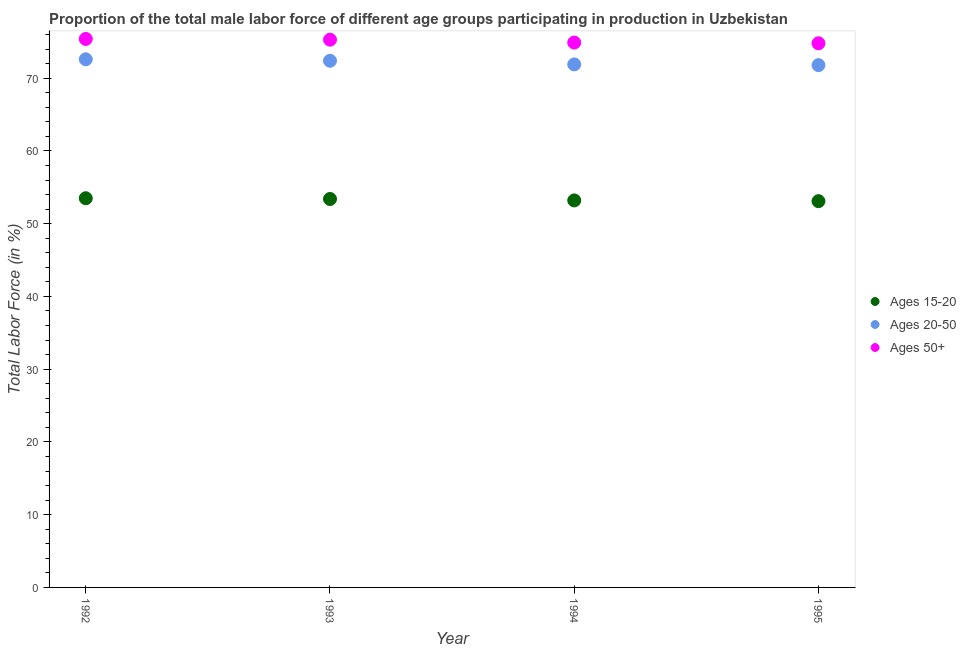How many different coloured dotlines are there?
Give a very brief answer. 3. Is the number of dotlines equal to the number of legend labels?
Offer a very short reply. Yes. What is the percentage of male labor force within the age group 15-20 in 1992?
Your answer should be compact. 53.5. Across all years, what is the maximum percentage of male labor force within the age group 15-20?
Keep it short and to the point. 53.5. Across all years, what is the minimum percentage of male labor force within the age group 20-50?
Offer a terse response. 71.8. In which year was the percentage of male labor force within the age group 15-20 maximum?
Make the answer very short. 1992. What is the total percentage of male labor force within the age group 15-20 in the graph?
Keep it short and to the point. 213.2. What is the difference between the percentage of male labor force within the age group 15-20 in 1992 and that in 1993?
Offer a very short reply. 0.1. What is the difference between the percentage of male labor force within the age group 15-20 in 1994 and the percentage of male labor force within the age group 20-50 in 1995?
Your response must be concise. -18.6. What is the average percentage of male labor force within the age group 15-20 per year?
Make the answer very short. 53.3. What is the ratio of the percentage of male labor force above age 50 in 1993 to that in 1995?
Provide a succinct answer. 1.01. Is the percentage of male labor force within the age group 20-50 in 1992 less than that in 1993?
Your response must be concise. No. Is the difference between the percentage of male labor force above age 50 in 1992 and 1993 greater than the difference between the percentage of male labor force within the age group 15-20 in 1992 and 1993?
Offer a very short reply. Yes. What is the difference between the highest and the second highest percentage of male labor force above age 50?
Ensure brevity in your answer.  0.1. What is the difference between the highest and the lowest percentage of male labor force within the age group 20-50?
Your answer should be compact. 0.8. In how many years, is the percentage of male labor force above age 50 greater than the average percentage of male labor force above age 50 taken over all years?
Give a very brief answer. 2. Does the percentage of male labor force above age 50 monotonically increase over the years?
Your answer should be very brief. No. Is the percentage of male labor force within the age group 20-50 strictly greater than the percentage of male labor force above age 50 over the years?
Your response must be concise. No. How many dotlines are there?
Ensure brevity in your answer.  3. Are the values on the major ticks of Y-axis written in scientific E-notation?
Your answer should be compact. No. Does the graph contain grids?
Keep it short and to the point. No. Where does the legend appear in the graph?
Your response must be concise. Center right. What is the title of the graph?
Give a very brief answer. Proportion of the total male labor force of different age groups participating in production in Uzbekistan. What is the label or title of the X-axis?
Offer a very short reply. Year. What is the label or title of the Y-axis?
Make the answer very short. Total Labor Force (in %). What is the Total Labor Force (in %) of Ages 15-20 in 1992?
Offer a very short reply. 53.5. What is the Total Labor Force (in %) in Ages 20-50 in 1992?
Provide a short and direct response. 72.6. What is the Total Labor Force (in %) in Ages 50+ in 1992?
Provide a short and direct response. 75.4. What is the Total Labor Force (in %) in Ages 15-20 in 1993?
Offer a very short reply. 53.4. What is the Total Labor Force (in %) in Ages 20-50 in 1993?
Your response must be concise. 72.4. What is the Total Labor Force (in %) in Ages 50+ in 1993?
Ensure brevity in your answer.  75.3. What is the Total Labor Force (in %) in Ages 15-20 in 1994?
Offer a terse response. 53.2. What is the Total Labor Force (in %) of Ages 20-50 in 1994?
Keep it short and to the point. 71.9. What is the Total Labor Force (in %) of Ages 50+ in 1994?
Offer a very short reply. 74.9. What is the Total Labor Force (in %) of Ages 15-20 in 1995?
Keep it short and to the point. 53.1. What is the Total Labor Force (in %) in Ages 20-50 in 1995?
Provide a short and direct response. 71.8. What is the Total Labor Force (in %) of Ages 50+ in 1995?
Keep it short and to the point. 74.8. Across all years, what is the maximum Total Labor Force (in %) of Ages 15-20?
Provide a succinct answer. 53.5. Across all years, what is the maximum Total Labor Force (in %) of Ages 20-50?
Offer a terse response. 72.6. Across all years, what is the maximum Total Labor Force (in %) of Ages 50+?
Provide a succinct answer. 75.4. Across all years, what is the minimum Total Labor Force (in %) in Ages 15-20?
Keep it short and to the point. 53.1. Across all years, what is the minimum Total Labor Force (in %) of Ages 20-50?
Make the answer very short. 71.8. Across all years, what is the minimum Total Labor Force (in %) in Ages 50+?
Ensure brevity in your answer.  74.8. What is the total Total Labor Force (in %) of Ages 15-20 in the graph?
Keep it short and to the point. 213.2. What is the total Total Labor Force (in %) of Ages 20-50 in the graph?
Ensure brevity in your answer.  288.7. What is the total Total Labor Force (in %) of Ages 50+ in the graph?
Give a very brief answer. 300.4. What is the difference between the Total Labor Force (in %) in Ages 15-20 in 1992 and that in 1993?
Keep it short and to the point. 0.1. What is the difference between the Total Labor Force (in %) of Ages 20-50 in 1992 and that in 1993?
Offer a very short reply. 0.2. What is the difference between the Total Labor Force (in %) of Ages 50+ in 1992 and that in 1994?
Your response must be concise. 0.5. What is the difference between the Total Labor Force (in %) of Ages 50+ in 1992 and that in 1995?
Your response must be concise. 0.6. What is the difference between the Total Labor Force (in %) of Ages 15-20 in 1993 and that in 1994?
Your answer should be compact. 0.2. What is the difference between the Total Labor Force (in %) of Ages 15-20 in 1993 and that in 1995?
Offer a very short reply. 0.3. What is the difference between the Total Labor Force (in %) of Ages 20-50 in 1993 and that in 1995?
Your answer should be very brief. 0.6. What is the difference between the Total Labor Force (in %) of Ages 50+ in 1994 and that in 1995?
Your answer should be compact. 0.1. What is the difference between the Total Labor Force (in %) in Ages 15-20 in 1992 and the Total Labor Force (in %) in Ages 20-50 in 1993?
Provide a succinct answer. -18.9. What is the difference between the Total Labor Force (in %) in Ages 15-20 in 1992 and the Total Labor Force (in %) in Ages 50+ in 1993?
Offer a very short reply. -21.8. What is the difference between the Total Labor Force (in %) in Ages 15-20 in 1992 and the Total Labor Force (in %) in Ages 20-50 in 1994?
Your answer should be compact. -18.4. What is the difference between the Total Labor Force (in %) in Ages 15-20 in 1992 and the Total Labor Force (in %) in Ages 50+ in 1994?
Keep it short and to the point. -21.4. What is the difference between the Total Labor Force (in %) in Ages 15-20 in 1992 and the Total Labor Force (in %) in Ages 20-50 in 1995?
Ensure brevity in your answer.  -18.3. What is the difference between the Total Labor Force (in %) of Ages 15-20 in 1992 and the Total Labor Force (in %) of Ages 50+ in 1995?
Provide a succinct answer. -21.3. What is the difference between the Total Labor Force (in %) in Ages 20-50 in 1992 and the Total Labor Force (in %) in Ages 50+ in 1995?
Make the answer very short. -2.2. What is the difference between the Total Labor Force (in %) of Ages 15-20 in 1993 and the Total Labor Force (in %) of Ages 20-50 in 1994?
Provide a short and direct response. -18.5. What is the difference between the Total Labor Force (in %) in Ages 15-20 in 1993 and the Total Labor Force (in %) in Ages 50+ in 1994?
Your answer should be very brief. -21.5. What is the difference between the Total Labor Force (in %) in Ages 20-50 in 1993 and the Total Labor Force (in %) in Ages 50+ in 1994?
Your answer should be compact. -2.5. What is the difference between the Total Labor Force (in %) of Ages 15-20 in 1993 and the Total Labor Force (in %) of Ages 20-50 in 1995?
Give a very brief answer. -18.4. What is the difference between the Total Labor Force (in %) of Ages 15-20 in 1993 and the Total Labor Force (in %) of Ages 50+ in 1995?
Keep it short and to the point. -21.4. What is the difference between the Total Labor Force (in %) in Ages 20-50 in 1993 and the Total Labor Force (in %) in Ages 50+ in 1995?
Your answer should be compact. -2.4. What is the difference between the Total Labor Force (in %) of Ages 15-20 in 1994 and the Total Labor Force (in %) of Ages 20-50 in 1995?
Keep it short and to the point. -18.6. What is the difference between the Total Labor Force (in %) of Ages 15-20 in 1994 and the Total Labor Force (in %) of Ages 50+ in 1995?
Keep it short and to the point. -21.6. What is the difference between the Total Labor Force (in %) in Ages 20-50 in 1994 and the Total Labor Force (in %) in Ages 50+ in 1995?
Your answer should be very brief. -2.9. What is the average Total Labor Force (in %) of Ages 15-20 per year?
Your answer should be very brief. 53.3. What is the average Total Labor Force (in %) in Ages 20-50 per year?
Offer a terse response. 72.17. What is the average Total Labor Force (in %) in Ages 50+ per year?
Give a very brief answer. 75.1. In the year 1992, what is the difference between the Total Labor Force (in %) in Ages 15-20 and Total Labor Force (in %) in Ages 20-50?
Offer a terse response. -19.1. In the year 1992, what is the difference between the Total Labor Force (in %) in Ages 15-20 and Total Labor Force (in %) in Ages 50+?
Offer a terse response. -21.9. In the year 1992, what is the difference between the Total Labor Force (in %) in Ages 20-50 and Total Labor Force (in %) in Ages 50+?
Your answer should be very brief. -2.8. In the year 1993, what is the difference between the Total Labor Force (in %) in Ages 15-20 and Total Labor Force (in %) in Ages 50+?
Provide a short and direct response. -21.9. In the year 1993, what is the difference between the Total Labor Force (in %) of Ages 20-50 and Total Labor Force (in %) of Ages 50+?
Offer a very short reply. -2.9. In the year 1994, what is the difference between the Total Labor Force (in %) of Ages 15-20 and Total Labor Force (in %) of Ages 20-50?
Offer a very short reply. -18.7. In the year 1994, what is the difference between the Total Labor Force (in %) in Ages 15-20 and Total Labor Force (in %) in Ages 50+?
Make the answer very short. -21.7. In the year 1994, what is the difference between the Total Labor Force (in %) of Ages 20-50 and Total Labor Force (in %) of Ages 50+?
Keep it short and to the point. -3. In the year 1995, what is the difference between the Total Labor Force (in %) of Ages 15-20 and Total Labor Force (in %) of Ages 20-50?
Keep it short and to the point. -18.7. In the year 1995, what is the difference between the Total Labor Force (in %) in Ages 15-20 and Total Labor Force (in %) in Ages 50+?
Make the answer very short. -21.7. What is the ratio of the Total Labor Force (in %) in Ages 15-20 in 1992 to that in 1994?
Provide a succinct answer. 1.01. What is the ratio of the Total Labor Force (in %) in Ages 20-50 in 1992 to that in 1994?
Your answer should be compact. 1.01. What is the ratio of the Total Labor Force (in %) of Ages 15-20 in 1992 to that in 1995?
Give a very brief answer. 1.01. What is the ratio of the Total Labor Force (in %) in Ages 20-50 in 1992 to that in 1995?
Keep it short and to the point. 1.01. What is the ratio of the Total Labor Force (in %) of Ages 50+ in 1992 to that in 1995?
Provide a succinct answer. 1.01. What is the ratio of the Total Labor Force (in %) in Ages 20-50 in 1993 to that in 1994?
Provide a succinct answer. 1.01. What is the ratio of the Total Labor Force (in %) in Ages 50+ in 1993 to that in 1994?
Your answer should be very brief. 1.01. What is the ratio of the Total Labor Force (in %) of Ages 15-20 in 1993 to that in 1995?
Offer a terse response. 1.01. What is the ratio of the Total Labor Force (in %) in Ages 20-50 in 1993 to that in 1995?
Provide a short and direct response. 1.01. What is the ratio of the Total Labor Force (in %) in Ages 15-20 in 1994 to that in 1995?
Offer a terse response. 1. What is the ratio of the Total Labor Force (in %) of Ages 20-50 in 1994 to that in 1995?
Offer a terse response. 1. What is the difference between the highest and the second highest Total Labor Force (in %) in Ages 15-20?
Offer a terse response. 0.1. What is the difference between the highest and the second highest Total Labor Force (in %) in Ages 20-50?
Give a very brief answer. 0.2. What is the difference between the highest and the lowest Total Labor Force (in %) in Ages 20-50?
Provide a short and direct response. 0.8. What is the difference between the highest and the lowest Total Labor Force (in %) in Ages 50+?
Keep it short and to the point. 0.6. 